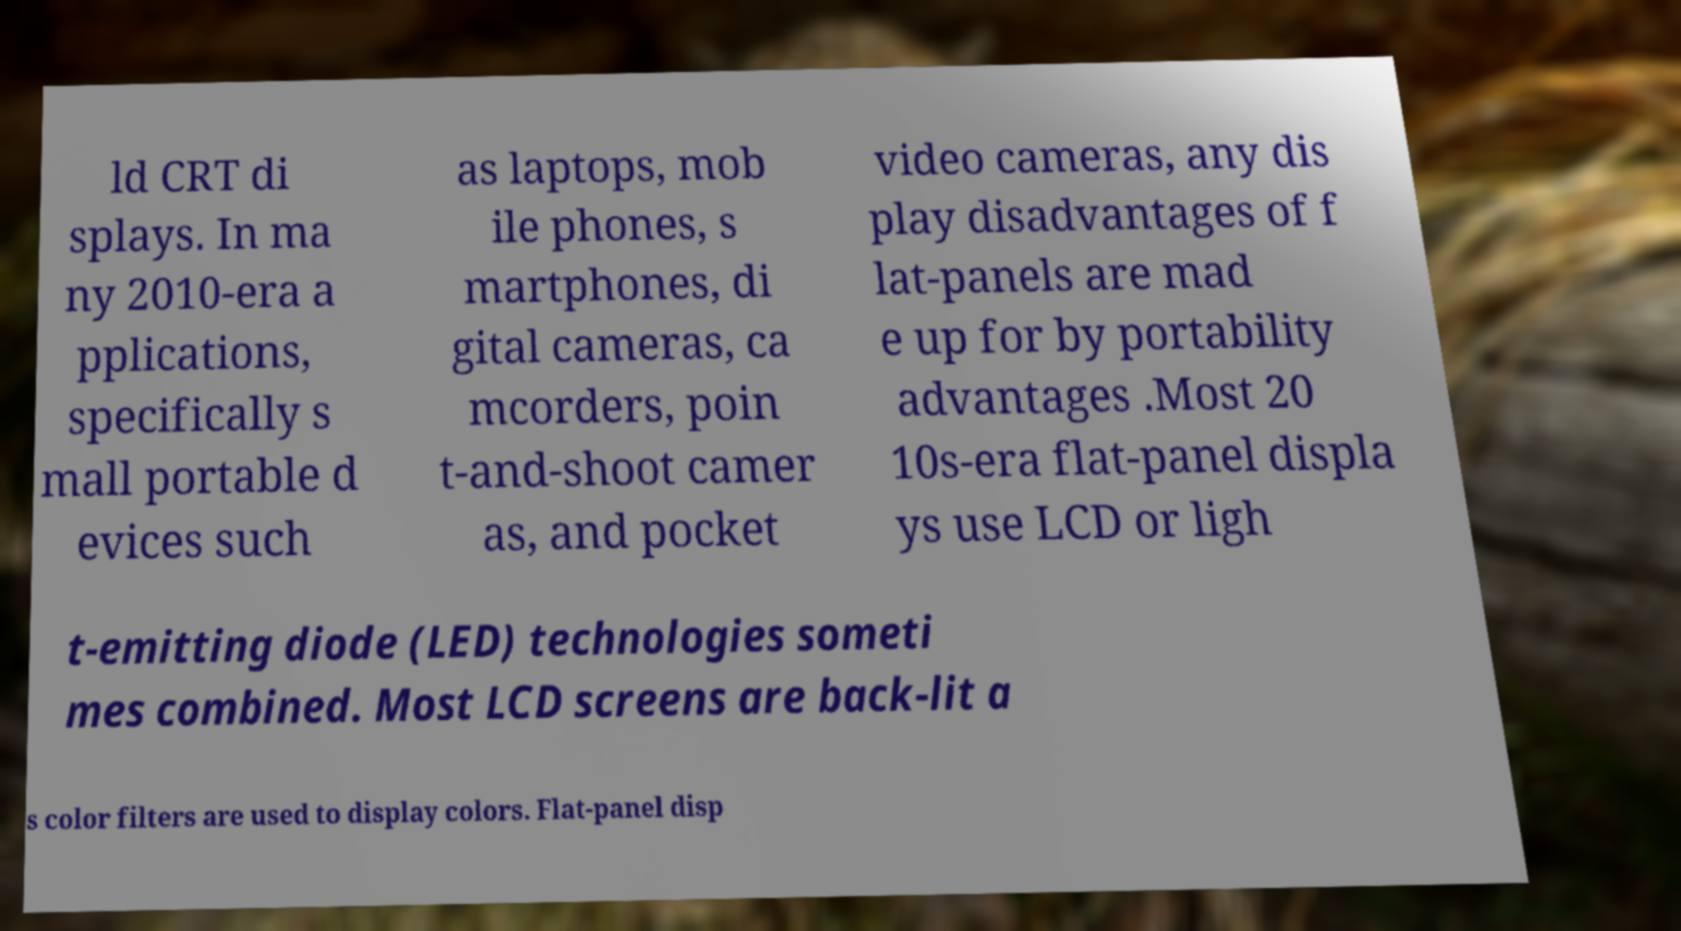There's text embedded in this image that I need extracted. Can you transcribe it verbatim? ld CRT di splays. In ma ny 2010-era a pplications, specifically s mall portable d evices such as laptops, mob ile phones, s martphones, di gital cameras, ca mcorders, poin t-and-shoot camer as, and pocket video cameras, any dis play disadvantages of f lat-panels are mad e up for by portability advantages .Most 20 10s-era flat-panel displa ys use LCD or ligh t-emitting diode (LED) technologies someti mes combined. Most LCD screens are back-lit a s color filters are used to display colors. Flat-panel disp 